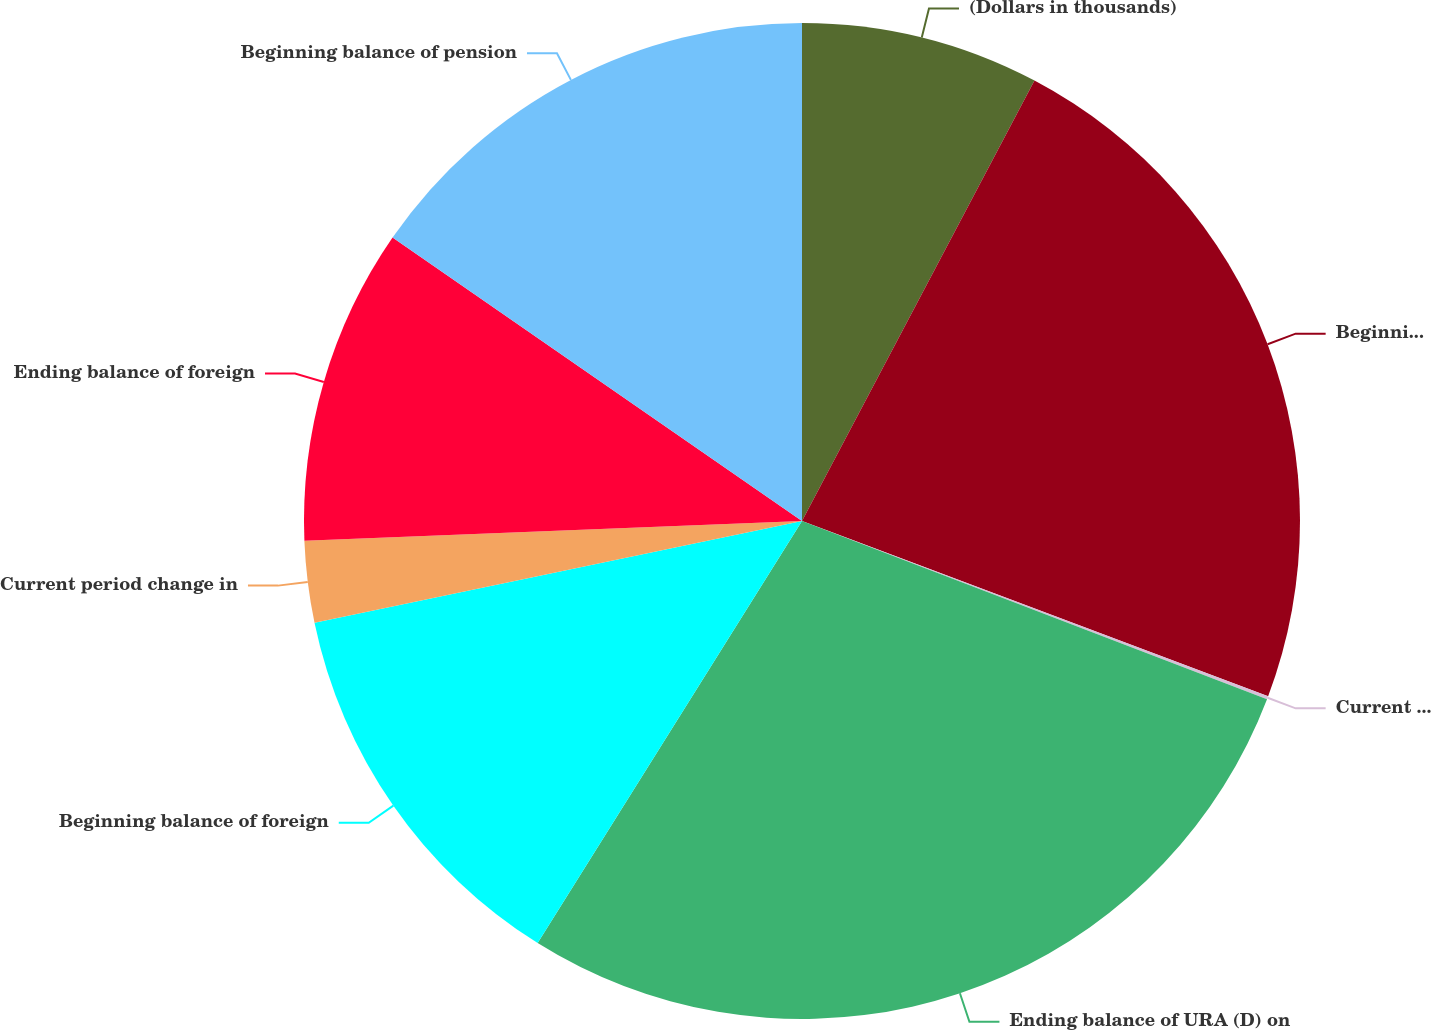Convert chart to OTSL. <chart><loc_0><loc_0><loc_500><loc_500><pie_chart><fcel>(Dollars in thousands)<fcel>Beginning balance of URA (D)<fcel>Current period change in URA<fcel>Ending balance of URA (D) on<fcel>Beginning balance of foreign<fcel>Current period change in<fcel>Ending balance of foreign<fcel>Beginning balance of pension<nl><fcel>7.73%<fcel>22.99%<fcel>0.1%<fcel>28.08%<fcel>12.82%<fcel>2.64%<fcel>10.27%<fcel>15.36%<nl></chart> 